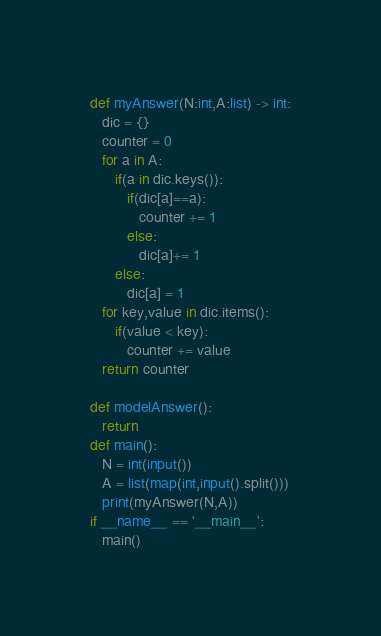<code> <loc_0><loc_0><loc_500><loc_500><_Python_>def myAnswer(N:int,A:list) -> int:
   dic = {}
   counter = 0
   for a in A:
      if(a in dic.keys()):
         if(dic[a]==a):
            counter += 1
         else:
            dic[a]+= 1
      else:
         dic[a] = 1
   for key,value in dic.items():
      if(value < key):
         counter += value
   return counter

def modelAnswer():
   return
def main():
   N = int(input())
   A = list(map(int,input().split()))
   print(myAnswer(N,A))
if __name__ == '__main__':
   main()</code> 